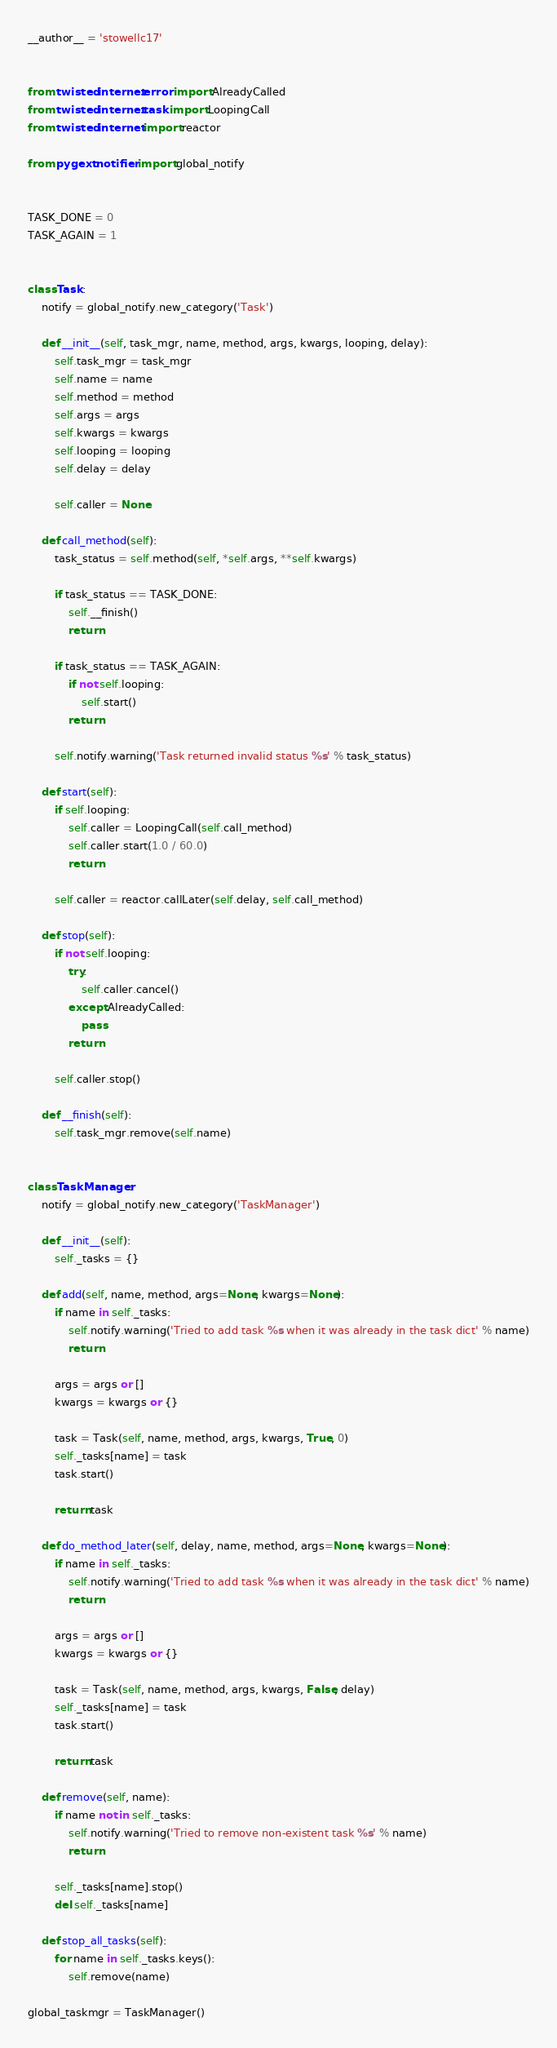Convert code to text. <code><loc_0><loc_0><loc_500><loc_500><_Python_>__author__ = 'stowellc17'


from twisted.internet.error import AlreadyCalled
from twisted.internet.task import LoopingCall
from twisted.internet import reactor

from pygext.notifier import global_notify


TASK_DONE = 0
TASK_AGAIN = 1


class Task:
    notify = global_notify.new_category('Task')

    def __init__(self, task_mgr, name, method, args, kwargs, looping, delay):
        self.task_mgr = task_mgr
        self.name = name
        self.method = method
        self.args = args
        self.kwargs = kwargs
        self.looping = looping
        self.delay = delay

        self.caller = None

    def call_method(self):
        task_status = self.method(self, *self.args, **self.kwargs)

        if task_status == TASK_DONE:
            self.__finish()
            return

        if task_status == TASK_AGAIN:
            if not self.looping:
                self.start()
            return

        self.notify.warning('Task returned invalid status %s' % task_status)

    def start(self):
        if self.looping:
            self.caller = LoopingCall(self.call_method)
            self.caller.start(1.0 / 60.0)
            return

        self.caller = reactor.callLater(self.delay, self.call_method)

    def stop(self):
        if not self.looping:
            try:
                self.caller.cancel()
            except AlreadyCalled:
                pass
            return

        self.caller.stop()

    def __finish(self):
        self.task_mgr.remove(self.name)


class TaskManager:
    notify = global_notify.new_category('TaskManager')

    def __init__(self):
        self._tasks = {}

    def add(self, name, method, args=None, kwargs=None):
        if name in self._tasks:
            self.notify.warning('Tried to add task %s when it was already in the task dict' % name)
            return

        args = args or []
        kwargs = kwargs or {}

        task = Task(self, name, method, args, kwargs, True, 0)
        self._tasks[name] = task
        task.start()

        return task

    def do_method_later(self, delay, name, method, args=None, kwargs=None):
        if name in self._tasks:
            self.notify.warning('Tried to add task %s when it was already in the task dict' % name)
            return

        args = args or []
        kwargs = kwargs or {}

        task = Task(self, name, method, args, kwargs, False, delay)
        self._tasks[name] = task
        task.start()

        return task

    def remove(self, name):
        if name not in self._tasks:
            self.notify.warning('Tried to remove non-existent task %s' % name)
            return

        self._tasks[name].stop()
        del self._tasks[name]

    def stop_all_tasks(self):
        for name in self._tasks.keys():
            self.remove(name)

global_taskmgr = TaskManager()
</code> 